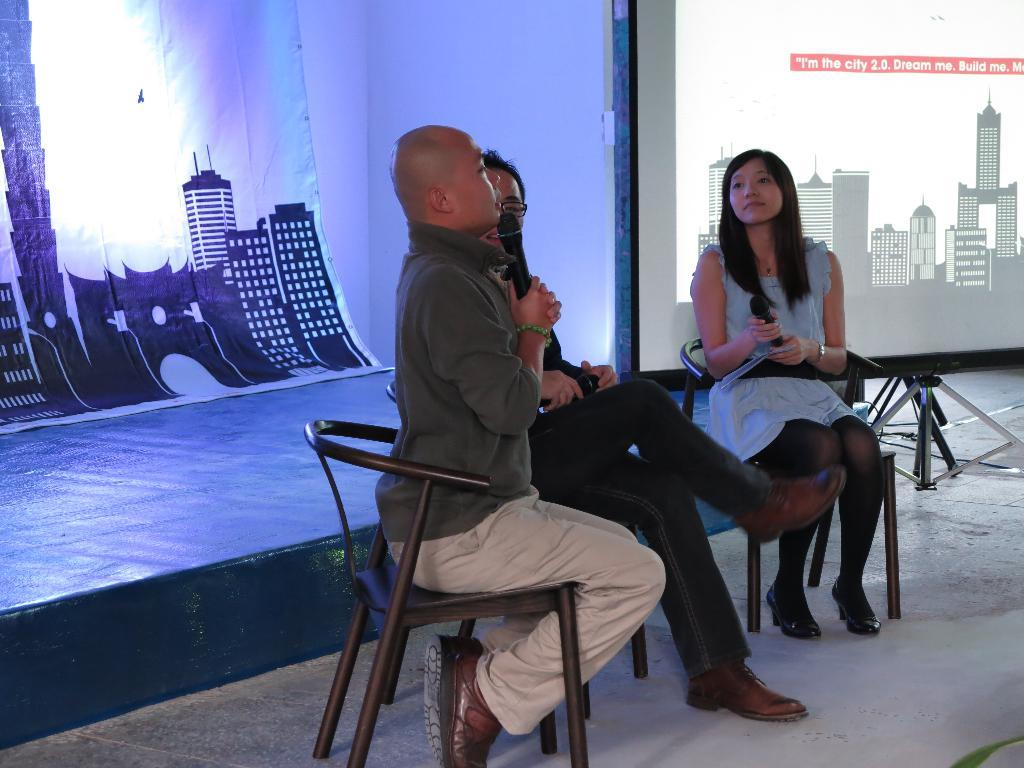How many people are sitting on the chair in the image? There are three persons sitting on a chair in the image. What are two of the persons holding? Two persons are holding a mic in the image. What can be seen on the stage in the image? There is a stage with a poster in the image. What is displayed on the screen in the image? There is a screen displaying buildings in the image. What is the income of the persons sitting on the chair in the image? There is no information about the income of the persons in the image. Can you describe the carriage used by the persons in the image? There is no carriage present in the image. 